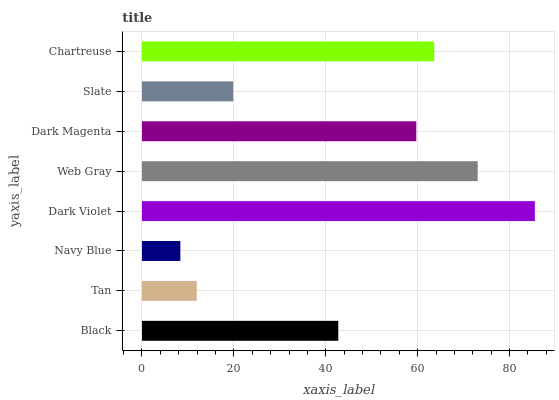Is Navy Blue the minimum?
Answer yes or no. Yes. Is Dark Violet the maximum?
Answer yes or no. Yes. Is Tan the minimum?
Answer yes or no. No. Is Tan the maximum?
Answer yes or no. No. Is Black greater than Tan?
Answer yes or no. Yes. Is Tan less than Black?
Answer yes or no. Yes. Is Tan greater than Black?
Answer yes or no. No. Is Black less than Tan?
Answer yes or no. No. Is Dark Magenta the high median?
Answer yes or no. Yes. Is Black the low median?
Answer yes or no. Yes. Is Slate the high median?
Answer yes or no. No. Is Navy Blue the low median?
Answer yes or no. No. 